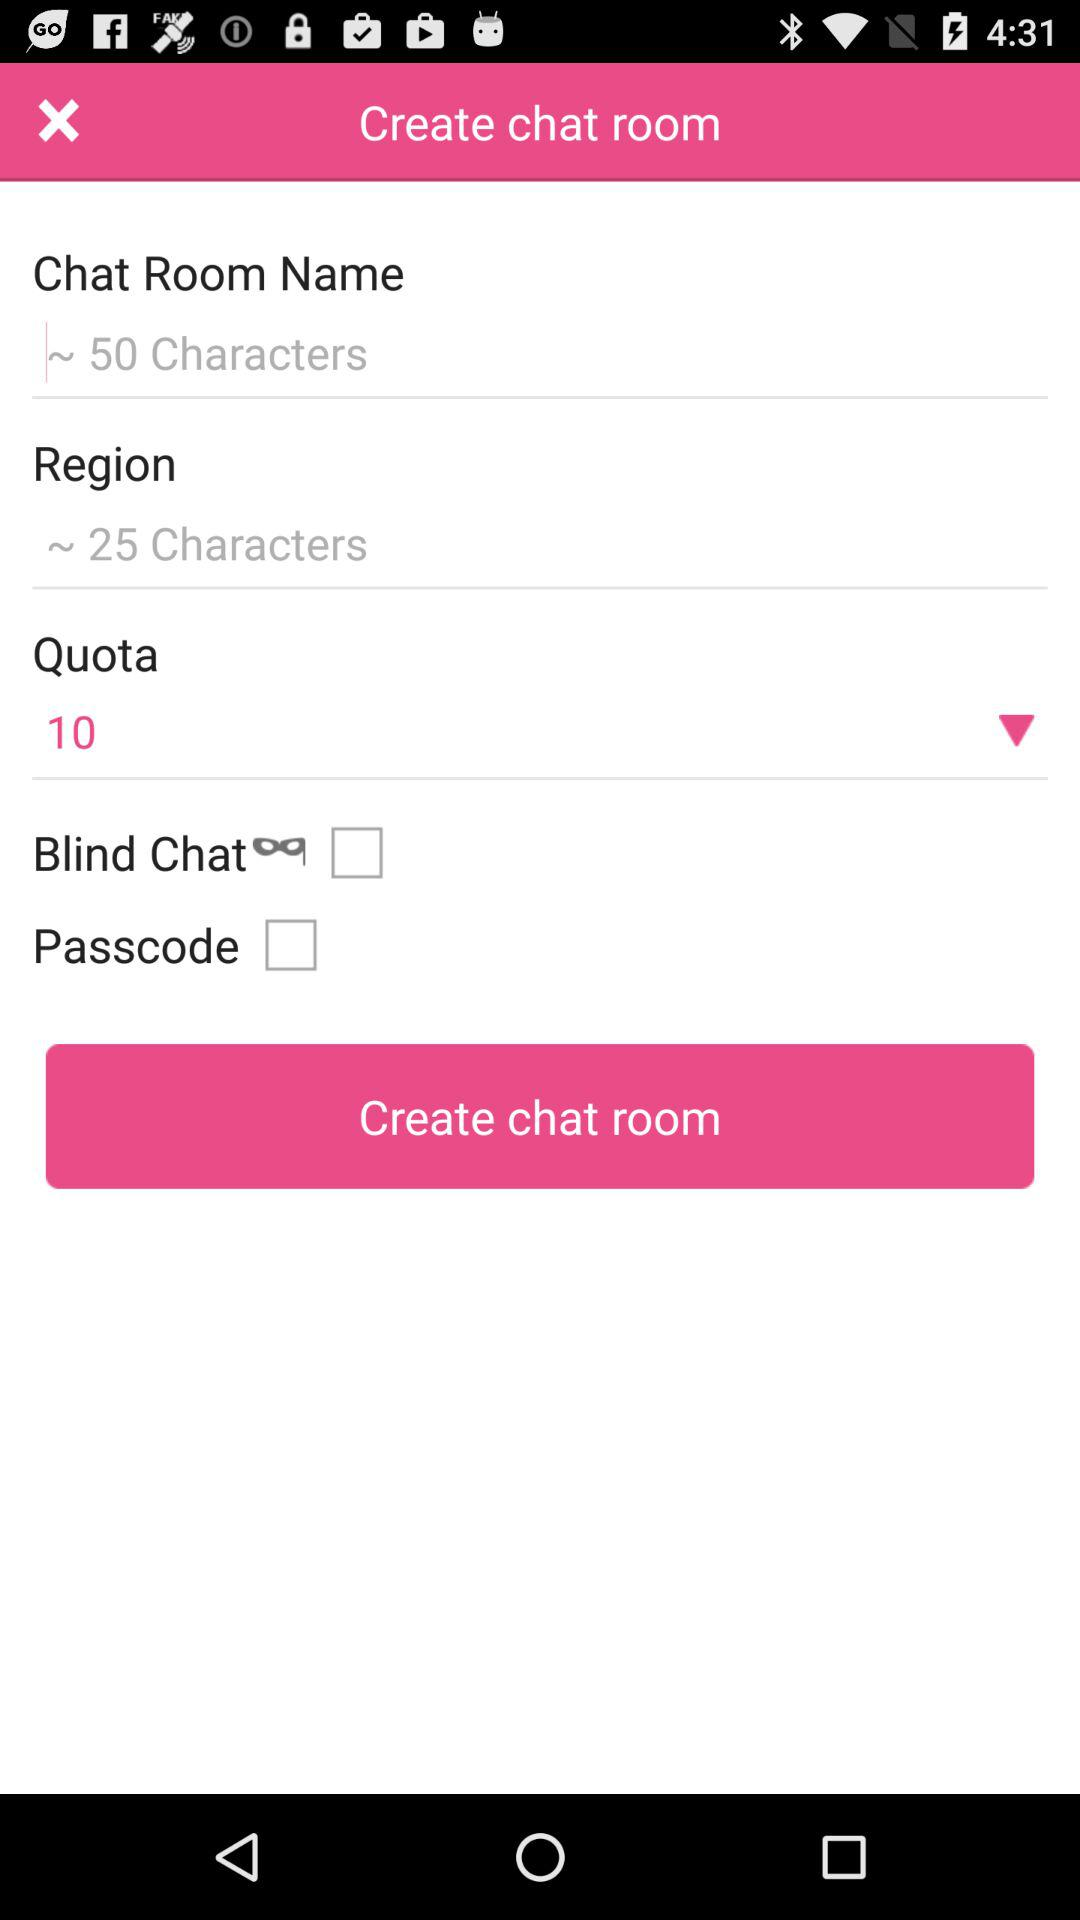What is the number in "Quota"? The number is 10. 